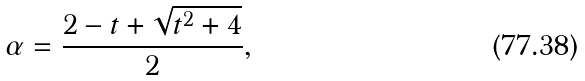<formula> <loc_0><loc_0><loc_500><loc_500>\alpha = \frac { 2 - t + \sqrt { t ^ { 2 } + 4 } } { 2 } ,</formula> 